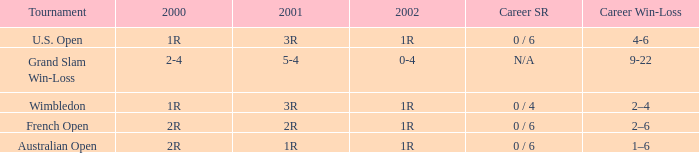In what year 2000 tournment did Angeles Montolio have a career win-loss record of 2-4? Grand Slam Win-Loss. 